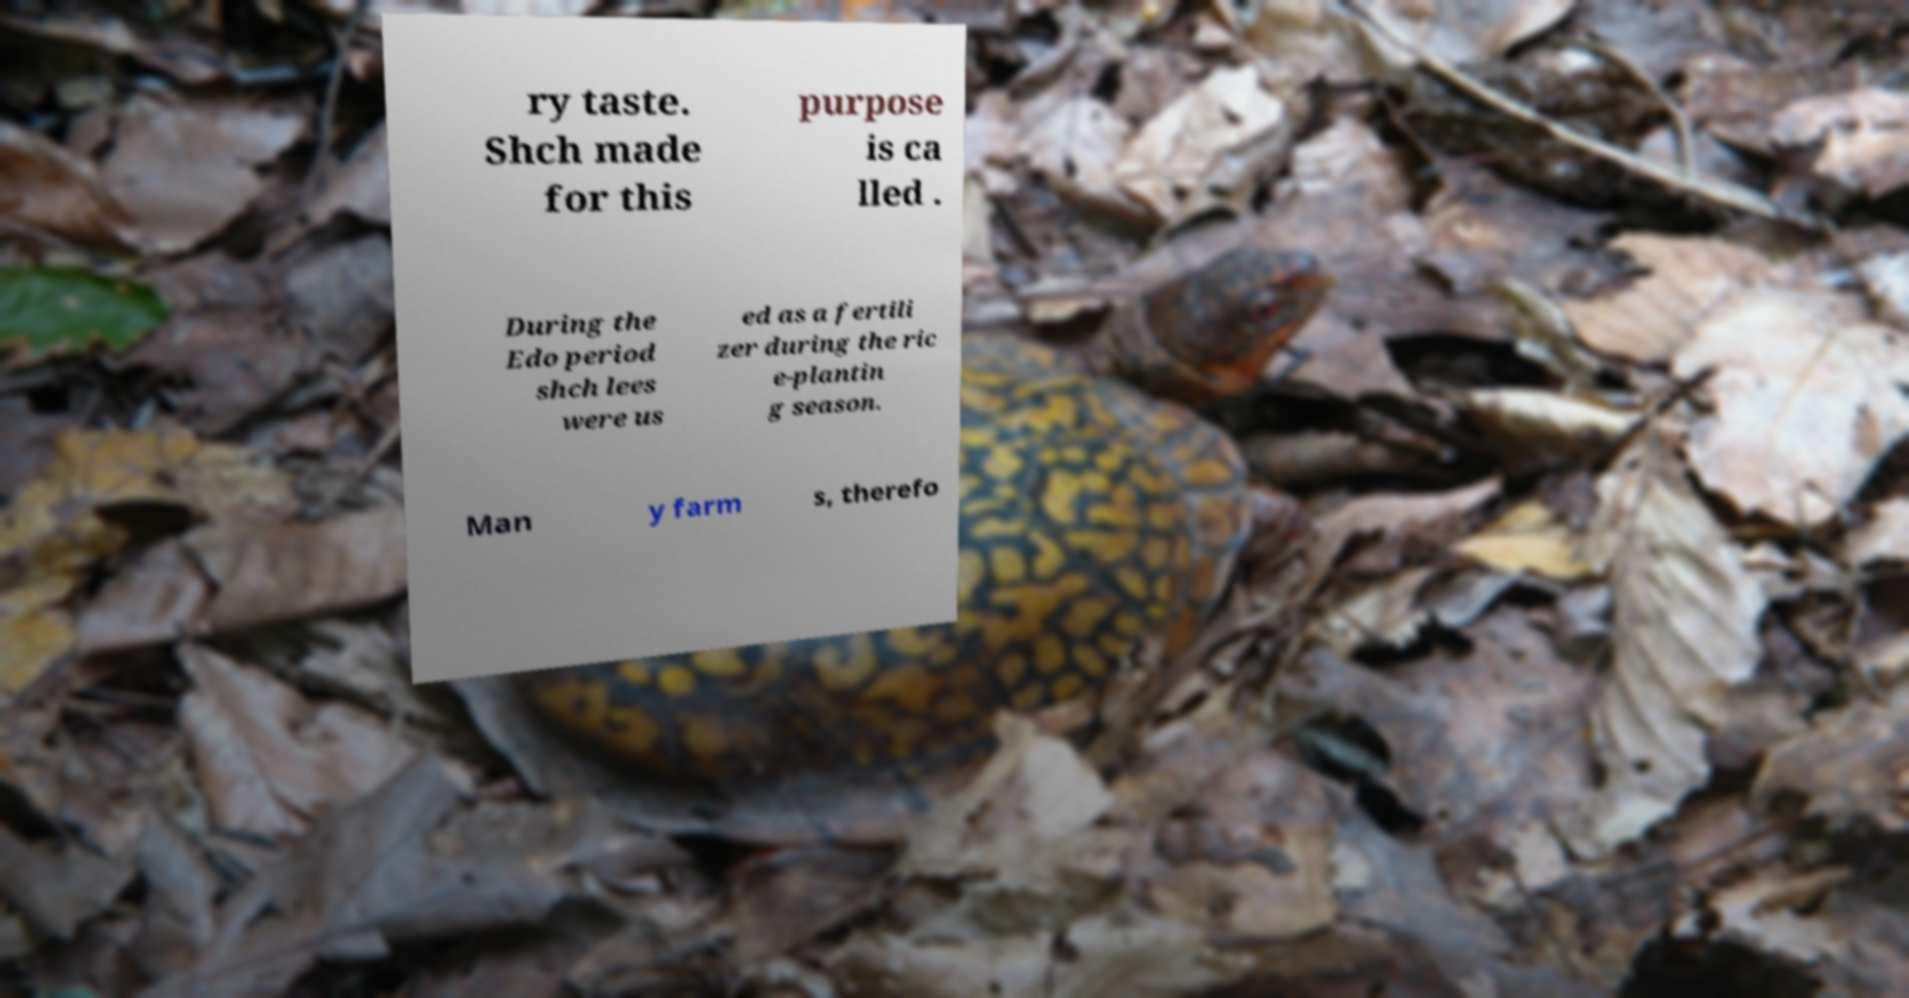Can you accurately transcribe the text from the provided image for me? ry taste. Shch made for this purpose is ca lled . During the Edo period shch lees were us ed as a fertili zer during the ric e-plantin g season. Man y farm s, therefo 